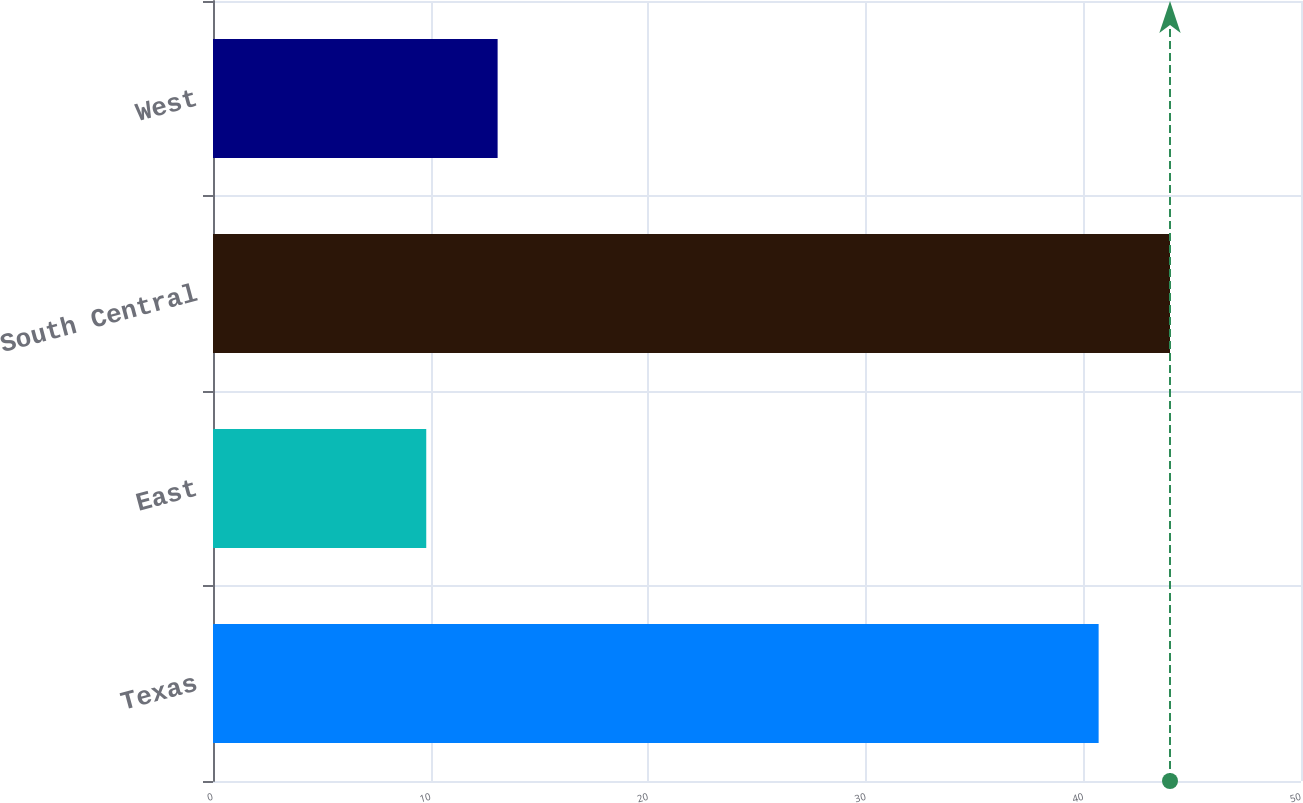<chart> <loc_0><loc_0><loc_500><loc_500><bar_chart><fcel>Texas<fcel>East<fcel>South Central<fcel>West<nl><fcel>40.7<fcel>9.8<fcel>43.98<fcel>13.08<nl></chart> 